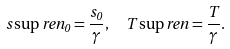<formula> <loc_0><loc_0><loc_500><loc_500>s \sup { r e n } _ { 0 } = \frac { s _ { 0 } } { \gamma } , \ \ T \sup { r e n } = \frac { T } { \gamma } .</formula> 